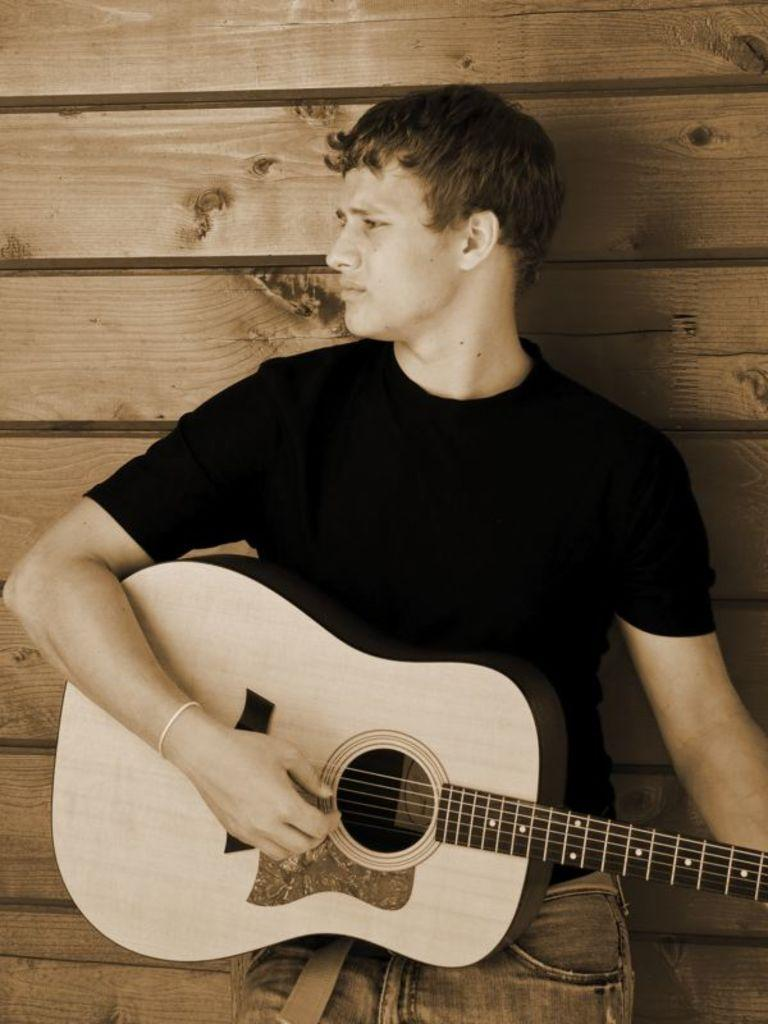Who is the main subject in the image? There is a man in the image. What is the man holding in the image? The man is holding a guitar. Where is the man positioned in the image? The man is standing at a wall. What type of heart-shaped object can be seen near the man in the image? There is no heart-shaped object present near the man in the image. 